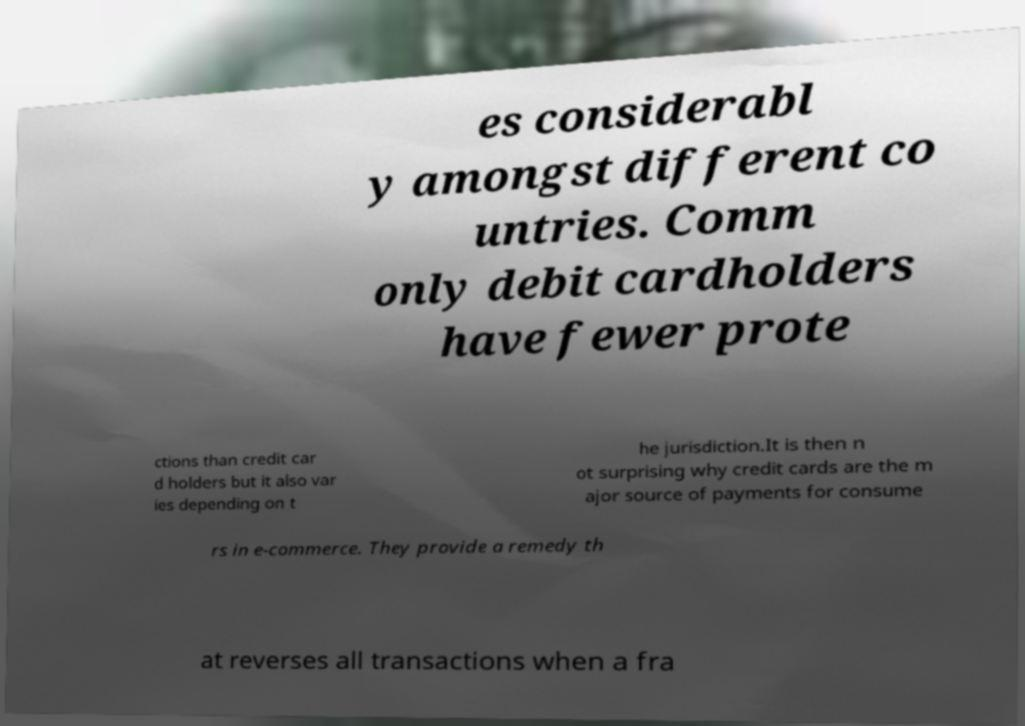Please identify and transcribe the text found in this image. es considerabl y amongst different co untries. Comm only debit cardholders have fewer prote ctions than credit car d holders but it also var ies depending on t he jurisdiction.It is then n ot surprising why credit cards are the m ajor source of payments for consume rs in e-commerce. They provide a remedy th at reverses all transactions when a fra 